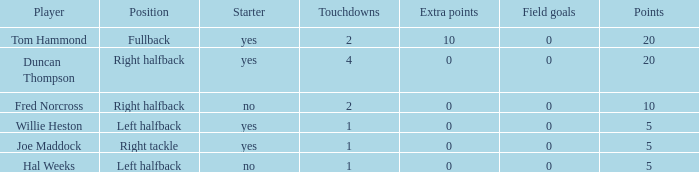What is the highest field goals when there were more than 1 touchdown and 0 extra points? 0.0. 